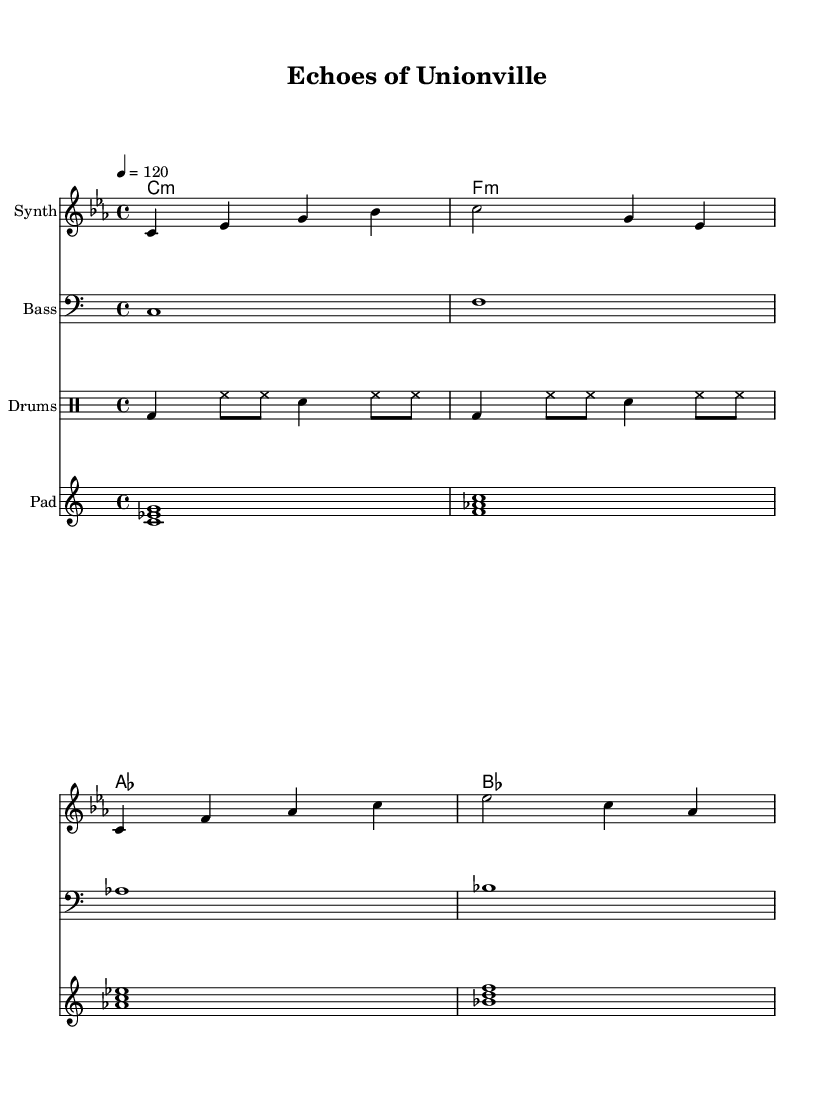What is the key signature of this music? The key signature is C minor, which consists of three flats: B flat, E flat, and A flat. This is indicated at the beginning of the score.
Answer: C minor What is the time signature of this music? The time signature is 4/4, which means there are four beats in each bar and a quarter note gets one beat. This is indicated at the beginning of the score.
Answer: 4/4 What is the tempo marking of the piece? The tempo marking is lively, indicating that the piece should be played at a speed of 120 beats per minute. This is indicated in the tempo section at the beginning of the score.
Answer: 120 How many different instruments are included in the score? There are four different instrument types included in the score: Synth, Bass, Drums, and Pad. Each is specified under different staves in the score.
Answer: Four What is the first note of the melody? The first note of the melody is C, which is played as a quarter note at the beginning of the melody section. This can be identified visually as the first note in the corresponding staff.
Answer: C What type of chord is used in the harmony section? The chords used in the harmony section are minor chords, noted by the lowercase "m" after the chord names (C:m, F:m, etc.). This reflects the style typical in electronic compositions.
Answer: Minor What rhythmic pattern is established by the drum part and how many bars does it cover? The rhythmic pattern consists of bass drum and hi-hat hits in a repeating sequence that covers two bars, as it is shown in the drum staff section. The bass drum typically hits on the first beat while the snare and hi-hat create a syncopated rhythm.
Answer: Two bars 